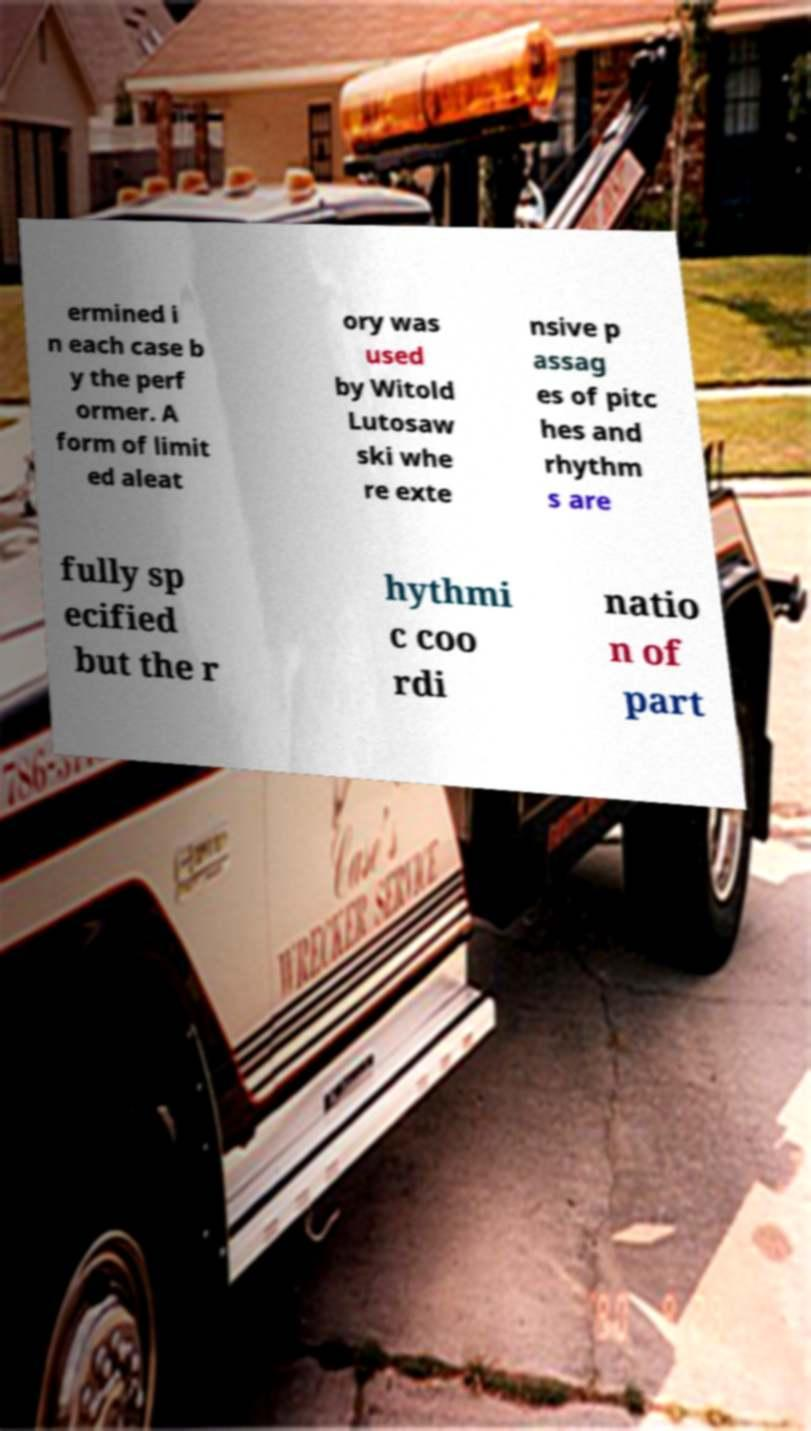Can you read and provide the text displayed in the image?This photo seems to have some interesting text. Can you extract and type it out for me? ermined i n each case b y the perf ormer. A form of limit ed aleat ory was used by Witold Lutosaw ski whe re exte nsive p assag es of pitc hes and rhythm s are fully sp ecified but the r hythmi c coo rdi natio n of part 